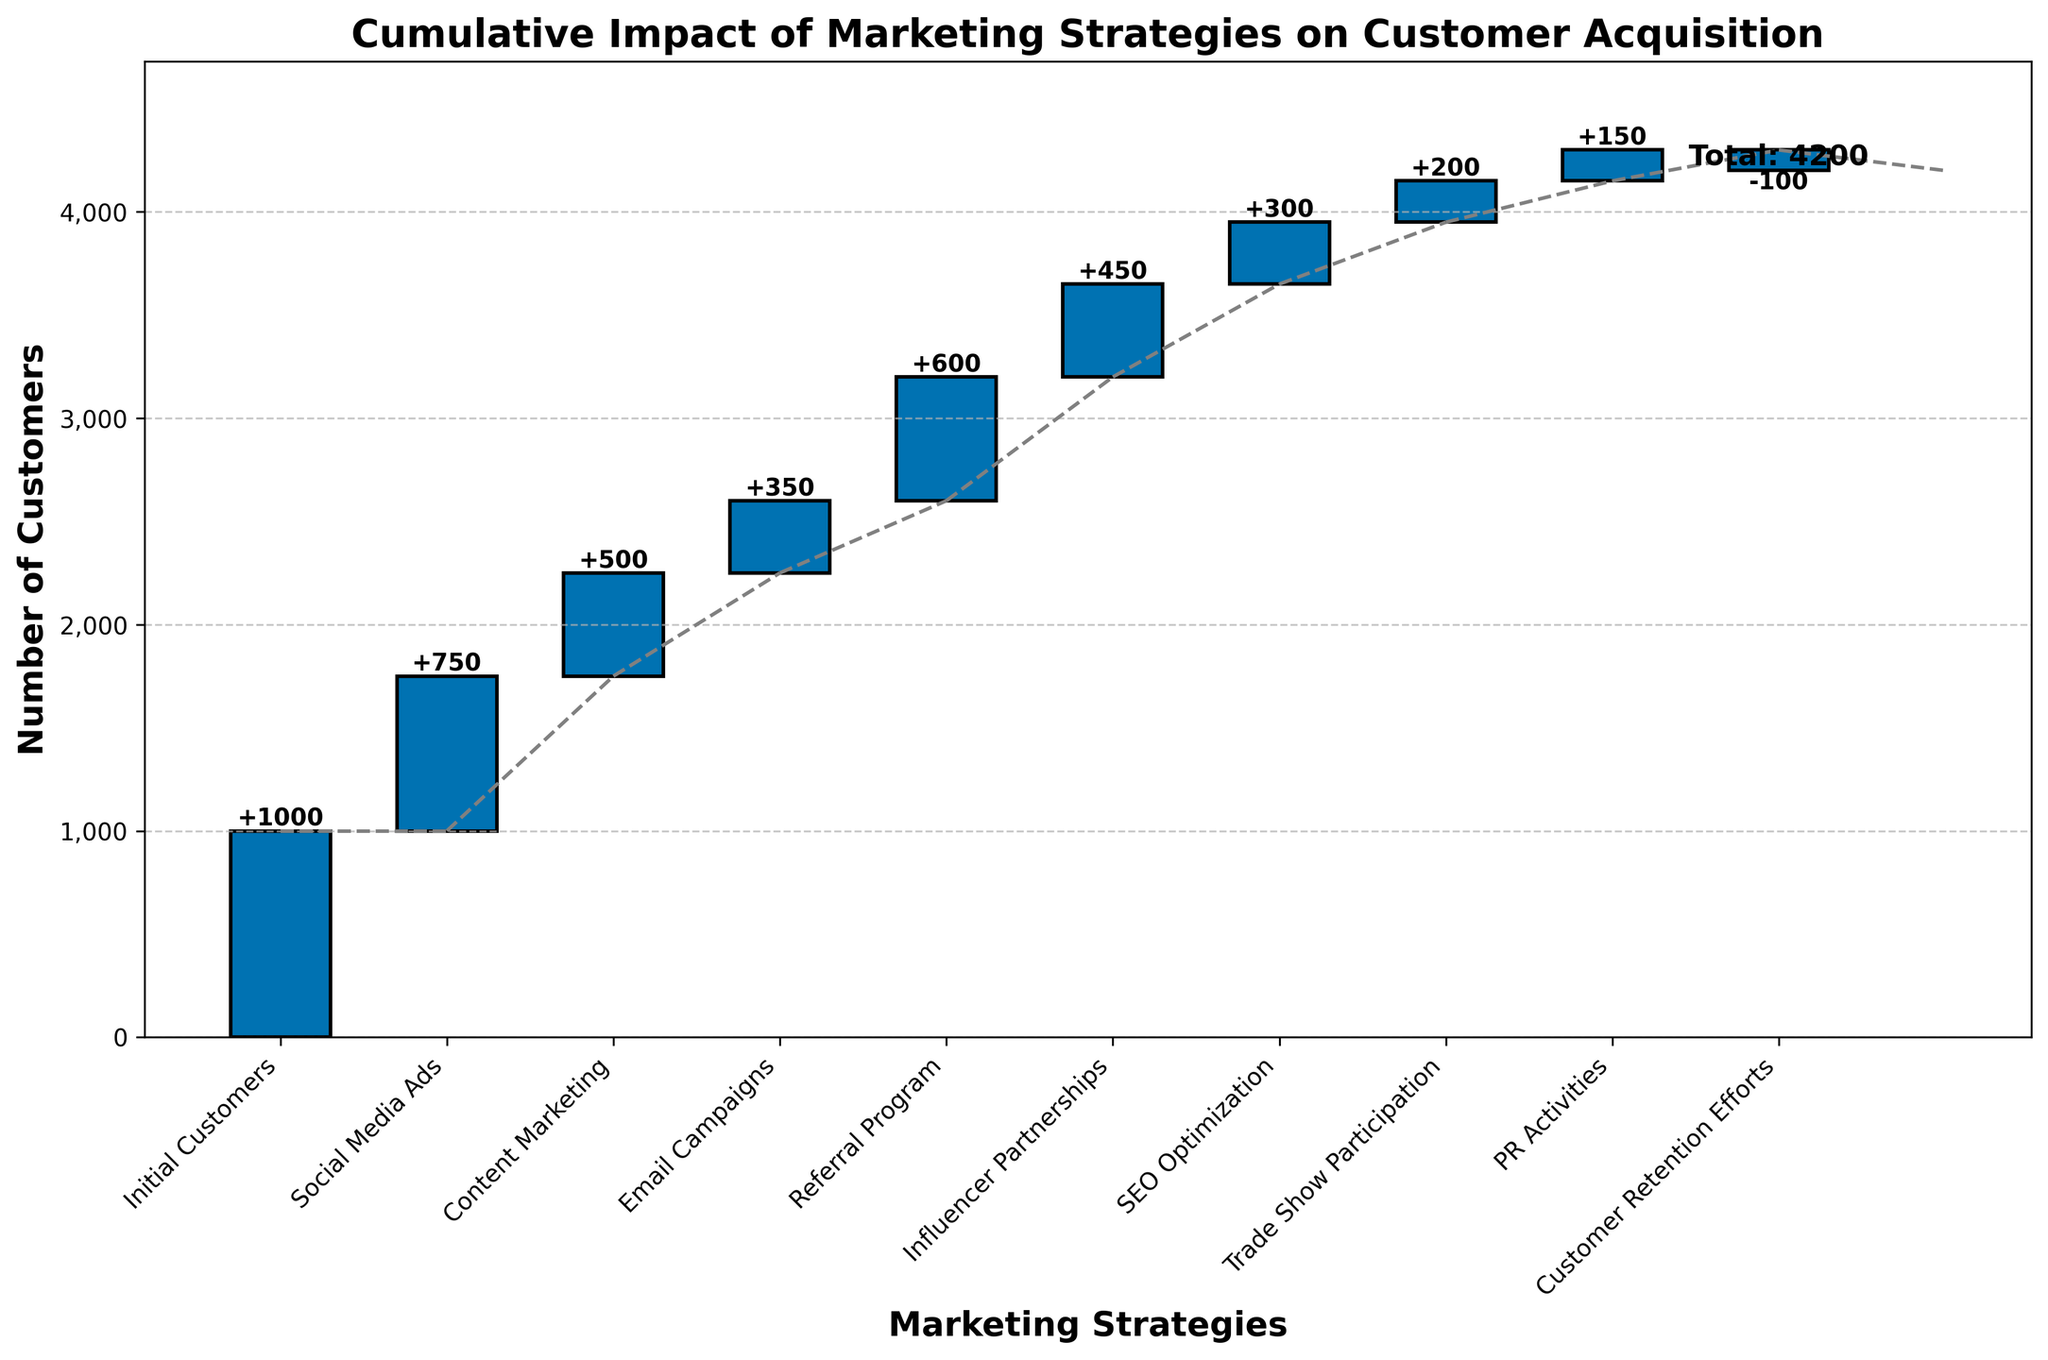What is the title of the chart? The title appears at the top of the chart and provides an overview of what the chart represents. By reading it, one can understand the main focus of the data visualized.
Answer: Cumulative Impact of Marketing Strategies on Customer Acquisition Which marketing strategy contributed the most to customer acquisition? The height of the bars represents the impact each strategy had on customer acquisition. The tallest bar will indicate the strategy with the highest positive impact.
Answer: Social Media Ads What is the total number of customers acquired after all marketing strategies are applied? The cumulative height of all bars, including the final "Total" label, represents the total customers acquired, as denoted at the end of the chart.
Answer: 4200 Which marketing strategy had a negative impact on customer acquisition? A bar with negative height (pointing downwards) indicates a decrease in customer acquisition.
Answer: Customer Retention Efforts What’s the combined impact of both Content Marketing and Email Campaigns on customer acquisition? To find the combined impact, sum the height of the bars for Content Marketing and Email Campaigns. Content Marketing adds 500, and Email Campaigns adds 350.
Answer: 850 How does the impact of Influencer Partnerships compare to SEO Optimization? To compare, look at the heights of the Influencer Partnerships and SEO Optimization bars. Influencer Partnerships add 450, while SEO Optimization adds 300.
Answer: Influencer Partnerships had a larger impact What is the cumulative impact on customer acquisition after Referral Program and Influencer Partnerships? To determine the cumulative impact, add the heights of the bars up to and including Influencer Partnerships. Initial Customers (1000) + Social Media Ads (750) + Content Marketing (500) + Email Campaigns (350) + Referral Program (600) + Influencer Partnerships (450) = 3650.
Answer: 3650 How much does Trade Show Participation contribute to the total customer base? The height of the Trade Show Participation bar indicates its contribution. Add this value as shown in the chart.
Answer: 200 What is the difference in impact between Social Media Ads and PR Activities? Subtract the height of the PR Activities bar from the height of the Social Media Ads bar. Social Media Ads add 750, while PR Activities add 150.
Answer: 600 How many strategies had a positive impact on customer acquisition? Count the bars that point upwards (positive height), indicating an increase in customer acquisition.
Answer: 8 